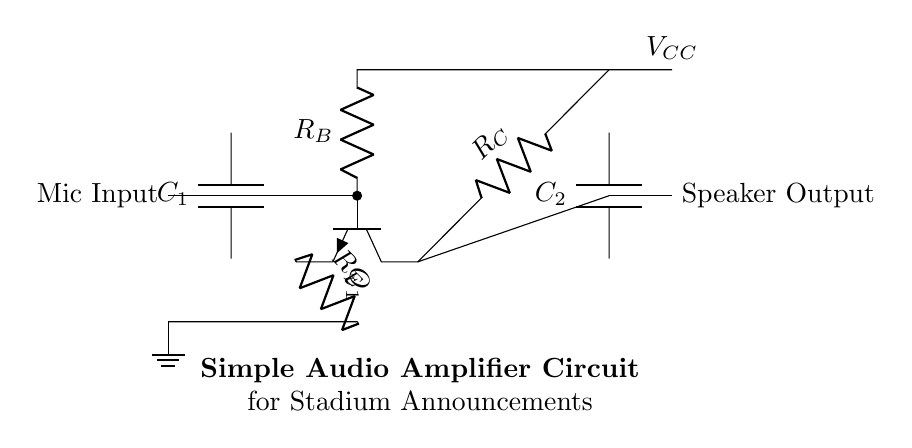What is the main component used for amplification? The main component used for amplification in this circuit is the transistor Q1, which is an NPN type. Transistors are essential in audio amplification circuits for boosting weak audio signals.
Answer: transistor Q1 What does the capacitor labeled C1 do? The capacitor C1 acts as a coupling capacitor that blocks DC voltage while allowing AC audio signals from the microphone input to pass to the transistor's base. This is crucial for preventing DC bias from interfering with audio signals.
Answer: blocks DC voltage How many resistors are present in the circuit? There are three resistors in this circuit: R_C, R_B, and R_E. Each resistor has a specific function in controlling biasing and stability in the amplifier circuit.
Answer: three resistors What is the output component of this amplifier? The output component of this amplifier is a speaker, which is indicated at the right side of the circuit. The purpose of the speaker is to convert the amplified audio signals from the circuit into sound.
Answer: speaker What role does R_E play in the amplifier circuit? R_E, or the emitter resistor, stabilizes the operating point of the transistor by providing negative feedback. This enhances the linearity and overall performance of the amplifier circuit.
Answer: stabilizes operating point What type of circuit is depicted here? This circuit is a simple audio amplifier circuit designed for stadium announcements and pre-match entertainment, highlighting its application context.
Answer: audio amplifier circuit 